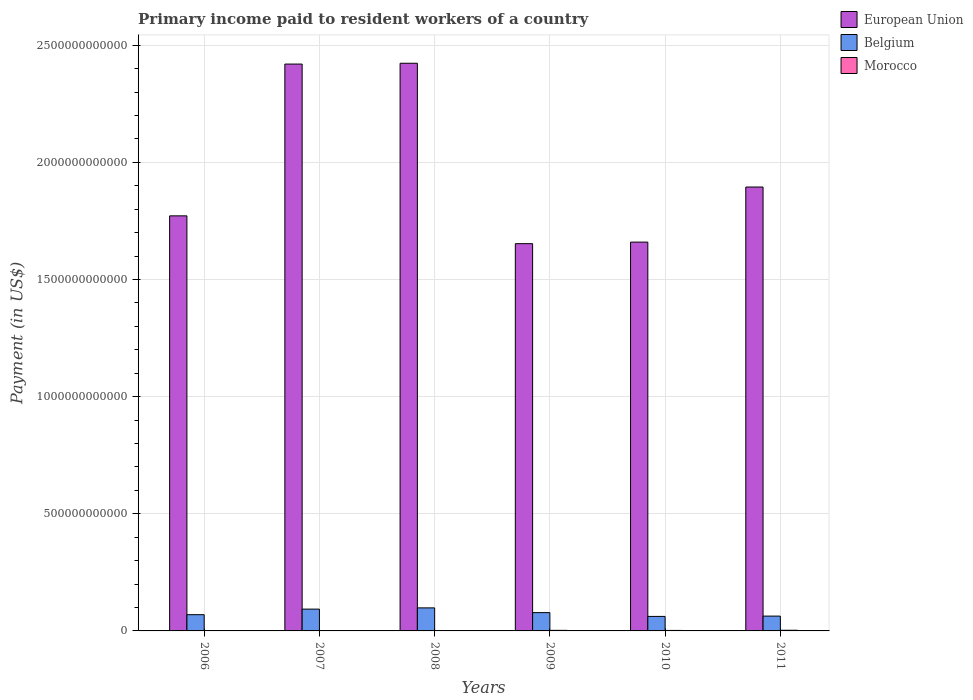How many different coloured bars are there?
Make the answer very short. 3. How many bars are there on the 1st tick from the left?
Give a very brief answer. 3. How many bars are there on the 3rd tick from the right?
Make the answer very short. 3. What is the label of the 3rd group of bars from the left?
Offer a very short reply. 2008. In how many cases, is the number of bars for a given year not equal to the number of legend labels?
Keep it short and to the point. 0. What is the amount paid to workers in Belgium in 2010?
Provide a short and direct response. 6.20e+1. Across all years, what is the maximum amount paid to workers in Morocco?
Keep it short and to the point. 2.86e+09. Across all years, what is the minimum amount paid to workers in European Union?
Offer a terse response. 1.65e+12. In which year was the amount paid to workers in Morocco minimum?
Offer a terse response. 2006. What is the total amount paid to workers in European Union in the graph?
Your response must be concise. 1.18e+13. What is the difference between the amount paid to workers in Morocco in 2009 and that in 2011?
Make the answer very short. -4.36e+08. What is the difference between the amount paid to workers in European Union in 2011 and the amount paid to workers in Morocco in 2008?
Make the answer very short. 1.89e+12. What is the average amount paid to workers in Morocco per year?
Keep it short and to the point. 1.93e+09. In the year 2011, what is the difference between the amount paid to workers in Morocco and amount paid to workers in Belgium?
Provide a short and direct response. -6.04e+1. What is the ratio of the amount paid to workers in Belgium in 2006 to that in 2010?
Offer a terse response. 1.12. Is the amount paid to workers in Belgium in 2008 less than that in 2011?
Provide a short and direct response. No. Is the difference between the amount paid to workers in Morocco in 2006 and 2009 greater than the difference between the amount paid to workers in Belgium in 2006 and 2009?
Keep it short and to the point. Yes. What is the difference between the highest and the second highest amount paid to workers in European Union?
Provide a succinct answer. 3.44e+09. What is the difference between the highest and the lowest amount paid to workers in European Union?
Your answer should be compact. 7.70e+11. Is the sum of the amount paid to workers in Morocco in 2007 and 2009 greater than the maximum amount paid to workers in Belgium across all years?
Make the answer very short. No. What does the 1st bar from the right in 2007 represents?
Give a very brief answer. Morocco. Is it the case that in every year, the sum of the amount paid to workers in Morocco and amount paid to workers in Belgium is greater than the amount paid to workers in European Union?
Keep it short and to the point. No. How many bars are there?
Make the answer very short. 18. Are all the bars in the graph horizontal?
Provide a succinct answer. No. What is the difference between two consecutive major ticks on the Y-axis?
Keep it short and to the point. 5.00e+11. Are the values on the major ticks of Y-axis written in scientific E-notation?
Offer a terse response. No. Does the graph contain any zero values?
Give a very brief answer. No. How many legend labels are there?
Your answer should be very brief. 3. What is the title of the graph?
Give a very brief answer. Primary income paid to resident workers of a country. Does "Costa Rica" appear as one of the legend labels in the graph?
Make the answer very short. No. What is the label or title of the Y-axis?
Offer a very short reply. Payment (in US$). What is the Payment (in US$) of European Union in 2006?
Offer a very short reply. 1.77e+12. What is the Payment (in US$) in Belgium in 2006?
Make the answer very short. 6.93e+1. What is the Payment (in US$) in Morocco in 2006?
Ensure brevity in your answer.  1.23e+09. What is the Payment (in US$) in European Union in 2007?
Provide a short and direct response. 2.42e+12. What is the Payment (in US$) of Belgium in 2007?
Offer a terse response. 9.31e+1. What is the Payment (in US$) of Morocco in 2007?
Provide a succinct answer. 1.37e+09. What is the Payment (in US$) of European Union in 2008?
Keep it short and to the point. 2.42e+12. What is the Payment (in US$) in Belgium in 2008?
Your answer should be compact. 9.83e+1. What is the Payment (in US$) in Morocco in 2008?
Keep it short and to the point. 1.58e+09. What is the Payment (in US$) of European Union in 2009?
Ensure brevity in your answer.  1.65e+12. What is the Payment (in US$) of Belgium in 2009?
Ensure brevity in your answer.  7.81e+1. What is the Payment (in US$) of Morocco in 2009?
Provide a short and direct response. 2.42e+09. What is the Payment (in US$) in European Union in 2010?
Provide a short and direct response. 1.66e+12. What is the Payment (in US$) in Belgium in 2010?
Your answer should be compact. 6.20e+1. What is the Payment (in US$) of Morocco in 2010?
Your answer should be compact. 2.11e+09. What is the Payment (in US$) of European Union in 2011?
Provide a short and direct response. 1.89e+12. What is the Payment (in US$) of Belgium in 2011?
Offer a terse response. 6.33e+1. What is the Payment (in US$) of Morocco in 2011?
Keep it short and to the point. 2.86e+09. Across all years, what is the maximum Payment (in US$) in European Union?
Your answer should be compact. 2.42e+12. Across all years, what is the maximum Payment (in US$) in Belgium?
Give a very brief answer. 9.83e+1. Across all years, what is the maximum Payment (in US$) of Morocco?
Offer a terse response. 2.86e+09. Across all years, what is the minimum Payment (in US$) in European Union?
Offer a very short reply. 1.65e+12. Across all years, what is the minimum Payment (in US$) of Belgium?
Make the answer very short. 6.20e+1. Across all years, what is the minimum Payment (in US$) in Morocco?
Your answer should be compact. 1.23e+09. What is the total Payment (in US$) in European Union in the graph?
Provide a succinct answer. 1.18e+13. What is the total Payment (in US$) in Belgium in the graph?
Your answer should be compact. 4.64e+11. What is the total Payment (in US$) of Morocco in the graph?
Keep it short and to the point. 1.16e+1. What is the difference between the Payment (in US$) of European Union in 2006 and that in 2007?
Make the answer very short. -6.48e+11. What is the difference between the Payment (in US$) of Belgium in 2006 and that in 2007?
Provide a succinct answer. -2.37e+1. What is the difference between the Payment (in US$) of Morocco in 2006 and that in 2007?
Make the answer very short. -1.39e+08. What is the difference between the Payment (in US$) in European Union in 2006 and that in 2008?
Your response must be concise. -6.51e+11. What is the difference between the Payment (in US$) in Belgium in 2006 and that in 2008?
Provide a succinct answer. -2.90e+1. What is the difference between the Payment (in US$) of Morocco in 2006 and that in 2008?
Make the answer very short. -3.54e+08. What is the difference between the Payment (in US$) of European Union in 2006 and that in 2009?
Offer a very short reply. 1.19e+11. What is the difference between the Payment (in US$) of Belgium in 2006 and that in 2009?
Provide a short and direct response. -8.79e+09. What is the difference between the Payment (in US$) of Morocco in 2006 and that in 2009?
Your answer should be compact. -1.19e+09. What is the difference between the Payment (in US$) in European Union in 2006 and that in 2010?
Ensure brevity in your answer.  1.12e+11. What is the difference between the Payment (in US$) in Belgium in 2006 and that in 2010?
Your answer should be compact. 7.37e+09. What is the difference between the Payment (in US$) in Morocco in 2006 and that in 2010?
Ensure brevity in your answer.  -8.83e+08. What is the difference between the Payment (in US$) of European Union in 2006 and that in 2011?
Make the answer very short. -1.23e+11. What is the difference between the Payment (in US$) in Belgium in 2006 and that in 2011?
Offer a very short reply. 6.03e+09. What is the difference between the Payment (in US$) of Morocco in 2006 and that in 2011?
Your answer should be very brief. -1.63e+09. What is the difference between the Payment (in US$) in European Union in 2007 and that in 2008?
Make the answer very short. -3.44e+09. What is the difference between the Payment (in US$) in Belgium in 2007 and that in 2008?
Provide a succinct answer. -5.27e+09. What is the difference between the Payment (in US$) of Morocco in 2007 and that in 2008?
Your answer should be very brief. -2.16e+08. What is the difference between the Payment (in US$) in European Union in 2007 and that in 2009?
Offer a terse response. 7.67e+11. What is the difference between the Payment (in US$) of Belgium in 2007 and that in 2009?
Make the answer very short. 1.50e+1. What is the difference between the Payment (in US$) in Morocco in 2007 and that in 2009?
Give a very brief answer. -1.06e+09. What is the difference between the Payment (in US$) of European Union in 2007 and that in 2010?
Your answer should be very brief. 7.60e+11. What is the difference between the Payment (in US$) of Belgium in 2007 and that in 2010?
Your answer should be very brief. 3.11e+1. What is the difference between the Payment (in US$) in Morocco in 2007 and that in 2010?
Keep it short and to the point. -7.45e+08. What is the difference between the Payment (in US$) in European Union in 2007 and that in 2011?
Make the answer very short. 5.25e+11. What is the difference between the Payment (in US$) of Belgium in 2007 and that in 2011?
Give a very brief answer. 2.98e+1. What is the difference between the Payment (in US$) in Morocco in 2007 and that in 2011?
Make the answer very short. -1.49e+09. What is the difference between the Payment (in US$) of European Union in 2008 and that in 2009?
Ensure brevity in your answer.  7.70e+11. What is the difference between the Payment (in US$) in Belgium in 2008 and that in 2009?
Your answer should be very brief. 2.02e+1. What is the difference between the Payment (in US$) of Morocco in 2008 and that in 2009?
Provide a short and direct response. -8.40e+08. What is the difference between the Payment (in US$) in European Union in 2008 and that in 2010?
Your response must be concise. 7.63e+11. What is the difference between the Payment (in US$) of Belgium in 2008 and that in 2010?
Make the answer very short. 3.64e+1. What is the difference between the Payment (in US$) of Morocco in 2008 and that in 2010?
Give a very brief answer. -5.29e+08. What is the difference between the Payment (in US$) in European Union in 2008 and that in 2011?
Provide a short and direct response. 5.28e+11. What is the difference between the Payment (in US$) in Belgium in 2008 and that in 2011?
Ensure brevity in your answer.  3.51e+1. What is the difference between the Payment (in US$) of Morocco in 2008 and that in 2011?
Give a very brief answer. -1.28e+09. What is the difference between the Payment (in US$) in European Union in 2009 and that in 2010?
Your response must be concise. -6.65e+09. What is the difference between the Payment (in US$) of Belgium in 2009 and that in 2010?
Make the answer very short. 1.62e+1. What is the difference between the Payment (in US$) of Morocco in 2009 and that in 2010?
Give a very brief answer. 3.10e+08. What is the difference between the Payment (in US$) in European Union in 2009 and that in 2011?
Keep it short and to the point. -2.42e+11. What is the difference between the Payment (in US$) in Belgium in 2009 and that in 2011?
Offer a very short reply. 1.48e+1. What is the difference between the Payment (in US$) in Morocco in 2009 and that in 2011?
Offer a terse response. -4.36e+08. What is the difference between the Payment (in US$) in European Union in 2010 and that in 2011?
Keep it short and to the point. -2.35e+11. What is the difference between the Payment (in US$) in Belgium in 2010 and that in 2011?
Your answer should be very brief. -1.34e+09. What is the difference between the Payment (in US$) in Morocco in 2010 and that in 2011?
Give a very brief answer. -7.46e+08. What is the difference between the Payment (in US$) in European Union in 2006 and the Payment (in US$) in Belgium in 2007?
Give a very brief answer. 1.68e+12. What is the difference between the Payment (in US$) in European Union in 2006 and the Payment (in US$) in Morocco in 2007?
Offer a very short reply. 1.77e+12. What is the difference between the Payment (in US$) of Belgium in 2006 and the Payment (in US$) of Morocco in 2007?
Give a very brief answer. 6.80e+1. What is the difference between the Payment (in US$) in European Union in 2006 and the Payment (in US$) in Belgium in 2008?
Your answer should be compact. 1.67e+12. What is the difference between the Payment (in US$) in European Union in 2006 and the Payment (in US$) in Morocco in 2008?
Offer a terse response. 1.77e+12. What is the difference between the Payment (in US$) of Belgium in 2006 and the Payment (in US$) of Morocco in 2008?
Make the answer very short. 6.77e+1. What is the difference between the Payment (in US$) of European Union in 2006 and the Payment (in US$) of Belgium in 2009?
Give a very brief answer. 1.69e+12. What is the difference between the Payment (in US$) in European Union in 2006 and the Payment (in US$) in Morocco in 2009?
Your response must be concise. 1.77e+12. What is the difference between the Payment (in US$) in Belgium in 2006 and the Payment (in US$) in Morocco in 2009?
Provide a short and direct response. 6.69e+1. What is the difference between the Payment (in US$) in European Union in 2006 and the Payment (in US$) in Belgium in 2010?
Offer a terse response. 1.71e+12. What is the difference between the Payment (in US$) in European Union in 2006 and the Payment (in US$) in Morocco in 2010?
Ensure brevity in your answer.  1.77e+12. What is the difference between the Payment (in US$) of Belgium in 2006 and the Payment (in US$) of Morocco in 2010?
Offer a very short reply. 6.72e+1. What is the difference between the Payment (in US$) in European Union in 2006 and the Payment (in US$) in Belgium in 2011?
Offer a very short reply. 1.71e+12. What is the difference between the Payment (in US$) in European Union in 2006 and the Payment (in US$) in Morocco in 2011?
Your response must be concise. 1.77e+12. What is the difference between the Payment (in US$) in Belgium in 2006 and the Payment (in US$) in Morocco in 2011?
Keep it short and to the point. 6.65e+1. What is the difference between the Payment (in US$) in European Union in 2007 and the Payment (in US$) in Belgium in 2008?
Make the answer very short. 2.32e+12. What is the difference between the Payment (in US$) of European Union in 2007 and the Payment (in US$) of Morocco in 2008?
Give a very brief answer. 2.42e+12. What is the difference between the Payment (in US$) of Belgium in 2007 and the Payment (in US$) of Morocco in 2008?
Make the answer very short. 9.15e+1. What is the difference between the Payment (in US$) in European Union in 2007 and the Payment (in US$) in Belgium in 2009?
Your answer should be compact. 2.34e+12. What is the difference between the Payment (in US$) in European Union in 2007 and the Payment (in US$) in Morocco in 2009?
Your response must be concise. 2.42e+12. What is the difference between the Payment (in US$) in Belgium in 2007 and the Payment (in US$) in Morocco in 2009?
Provide a short and direct response. 9.07e+1. What is the difference between the Payment (in US$) of European Union in 2007 and the Payment (in US$) of Belgium in 2010?
Make the answer very short. 2.36e+12. What is the difference between the Payment (in US$) in European Union in 2007 and the Payment (in US$) in Morocco in 2010?
Ensure brevity in your answer.  2.42e+12. What is the difference between the Payment (in US$) of Belgium in 2007 and the Payment (in US$) of Morocco in 2010?
Provide a succinct answer. 9.10e+1. What is the difference between the Payment (in US$) in European Union in 2007 and the Payment (in US$) in Belgium in 2011?
Your answer should be very brief. 2.36e+12. What is the difference between the Payment (in US$) of European Union in 2007 and the Payment (in US$) of Morocco in 2011?
Your answer should be very brief. 2.42e+12. What is the difference between the Payment (in US$) in Belgium in 2007 and the Payment (in US$) in Morocco in 2011?
Keep it short and to the point. 9.02e+1. What is the difference between the Payment (in US$) in European Union in 2008 and the Payment (in US$) in Belgium in 2009?
Offer a very short reply. 2.35e+12. What is the difference between the Payment (in US$) of European Union in 2008 and the Payment (in US$) of Morocco in 2009?
Ensure brevity in your answer.  2.42e+12. What is the difference between the Payment (in US$) in Belgium in 2008 and the Payment (in US$) in Morocco in 2009?
Offer a very short reply. 9.59e+1. What is the difference between the Payment (in US$) of European Union in 2008 and the Payment (in US$) of Belgium in 2010?
Provide a short and direct response. 2.36e+12. What is the difference between the Payment (in US$) of European Union in 2008 and the Payment (in US$) of Morocco in 2010?
Offer a very short reply. 2.42e+12. What is the difference between the Payment (in US$) of Belgium in 2008 and the Payment (in US$) of Morocco in 2010?
Keep it short and to the point. 9.62e+1. What is the difference between the Payment (in US$) of European Union in 2008 and the Payment (in US$) of Belgium in 2011?
Your answer should be very brief. 2.36e+12. What is the difference between the Payment (in US$) in European Union in 2008 and the Payment (in US$) in Morocco in 2011?
Your response must be concise. 2.42e+12. What is the difference between the Payment (in US$) of Belgium in 2008 and the Payment (in US$) of Morocco in 2011?
Offer a terse response. 9.55e+1. What is the difference between the Payment (in US$) of European Union in 2009 and the Payment (in US$) of Belgium in 2010?
Make the answer very short. 1.59e+12. What is the difference between the Payment (in US$) in European Union in 2009 and the Payment (in US$) in Morocco in 2010?
Provide a short and direct response. 1.65e+12. What is the difference between the Payment (in US$) of Belgium in 2009 and the Payment (in US$) of Morocco in 2010?
Provide a succinct answer. 7.60e+1. What is the difference between the Payment (in US$) in European Union in 2009 and the Payment (in US$) in Belgium in 2011?
Your response must be concise. 1.59e+12. What is the difference between the Payment (in US$) in European Union in 2009 and the Payment (in US$) in Morocco in 2011?
Your answer should be compact. 1.65e+12. What is the difference between the Payment (in US$) in Belgium in 2009 and the Payment (in US$) in Morocco in 2011?
Offer a terse response. 7.53e+1. What is the difference between the Payment (in US$) in European Union in 2010 and the Payment (in US$) in Belgium in 2011?
Your answer should be compact. 1.60e+12. What is the difference between the Payment (in US$) of European Union in 2010 and the Payment (in US$) of Morocco in 2011?
Offer a terse response. 1.66e+12. What is the difference between the Payment (in US$) of Belgium in 2010 and the Payment (in US$) of Morocco in 2011?
Your answer should be very brief. 5.91e+1. What is the average Payment (in US$) in European Union per year?
Give a very brief answer. 1.97e+12. What is the average Payment (in US$) of Belgium per year?
Give a very brief answer. 7.73e+1. What is the average Payment (in US$) in Morocco per year?
Your answer should be compact. 1.93e+09. In the year 2006, what is the difference between the Payment (in US$) in European Union and Payment (in US$) in Belgium?
Offer a very short reply. 1.70e+12. In the year 2006, what is the difference between the Payment (in US$) in European Union and Payment (in US$) in Morocco?
Your answer should be compact. 1.77e+12. In the year 2006, what is the difference between the Payment (in US$) of Belgium and Payment (in US$) of Morocco?
Provide a succinct answer. 6.81e+1. In the year 2007, what is the difference between the Payment (in US$) of European Union and Payment (in US$) of Belgium?
Offer a very short reply. 2.33e+12. In the year 2007, what is the difference between the Payment (in US$) of European Union and Payment (in US$) of Morocco?
Offer a very short reply. 2.42e+12. In the year 2007, what is the difference between the Payment (in US$) in Belgium and Payment (in US$) in Morocco?
Ensure brevity in your answer.  9.17e+1. In the year 2008, what is the difference between the Payment (in US$) in European Union and Payment (in US$) in Belgium?
Provide a short and direct response. 2.32e+12. In the year 2008, what is the difference between the Payment (in US$) in European Union and Payment (in US$) in Morocco?
Ensure brevity in your answer.  2.42e+12. In the year 2008, what is the difference between the Payment (in US$) in Belgium and Payment (in US$) in Morocco?
Offer a terse response. 9.68e+1. In the year 2009, what is the difference between the Payment (in US$) of European Union and Payment (in US$) of Belgium?
Make the answer very short. 1.57e+12. In the year 2009, what is the difference between the Payment (in US$) of European Union and Payment (in US$) of Morocco?
Offer a very short reply. 1.65e+12. In the year 2009, what is the difference between the Payment (in US$) in Belgium and Payment (in US$) in Morocco?
Your answer should be very brief. 7.57e+1. In the year 2010, what is the difference between the Payment (in US$) of European Union and Payment (in US$) of Belgium?
Your response must be concise. 1.60e+12. In the year 2010, what is the difference between the Payment (in US$) of European Union and Payment (in US$) of Morocco?
Provide a succinct answer. 1.66e+12. In the year 2010, what is the difference between the Payment (in US$) of Belgium and Payment (in US$) of Morocco?
Your response must be concise. 5.98e+1. In the year 2011, what is the difference between the Payment (in US$) of European Union and Payment (in US$) of Belgium?
Provide a short and direct response. 1.83e+12. In the year 2011, what is the difference between the Payment (in US$) of European Union and Payment (in US$) of Morocco?
Your response must be concise. 1.89e+12. In the year 2011, what is the difference between the Payment (in US$) of Belgium and Payment (in US$) of Morocco?
Your answer should be compact. 6.04e+1. What is the ratio of the Payment (in US$) in European Union in 2006 to that in 2007?
Make the answer very short. 0.73. What is the ratio of the Payment (in US$) in Belgium in 2006 to that in 2007?
Your response must be concise. 0.74. What is the ratio of the Payment (in US$) in Morocco in 2006 to that in 2007?
Provide a short and direct response. 0.9. What is the ratio of the Payment (in US$) in European Union in 2006 to that in 2008?
Provide a short and direct response. 0.73. What is the ratio of the Payment (in US$) of Belgium in 2006 to that in 2008?
Make the answer very short. 0.7. What is the ratio of the Payment (in US$) in Morocco in 2006 to that in 2008?
Offer a terse response. 0.78. What is the ratio of the Payment (in US$) of European Union in 2006 to that in 2009?
Keep it short and to the point. 1.07. What is the ratio of the Payment (in US$) of Belgium in 2006 to that in 2009?
Ensure brevity in your answer.  0.89. What is the ratio of the Payment (in US$) in Morocco in 2006 to that in 2009?
Keep it short and to the point. 0.51. What is the ratio of the Payment (in US$) of European Union in 2006 to that in 2010?
Give a very brief answer. 1.07. What is the ratio of the Payment (in US$) in Belgium in 2006 to that in 2010?
Your response must be concise. 1.12. What is the ratio of the Payment (in US$) of Morocco in 2006 to that in 2010?
Your answer should be very brief. 0.58. What is the ratio of the Payment (in US$) of European Union in 2006 to that in 2011?
Your answer should be compact. 0.94. What is the ratio of the Payment (in US$) of Belgium in 2006 to that in 2011?
Offer a terse response. 1.1. What is the ratio of the Payment (in US$) in Morocco in 2006 to that in 2011?
Offer a terse response. 0.43. What is the ratio of the Payment (in US$) in Belgium in 2007 to that in 2008?
Your answer should be very brief. 0.95. What is the ratio of the Payment (in US$) in Morocco in 2007 to that in 2008?
Ensure brevity in your answer.  0.86. What is the ratio of the Payment (in US$) in European Union in 2007 to that in 2009?
Provide a succinct answer. 1.46. What is the ratio of the Payment (in US$) in Belgium in 2007 to that in 2009?
Provide a succinct answer. 1.19. What is the ratio of the Payment (in US$) in Morocco in 2007 to that in 2009?
Provide a short and direct response. 0.56. What is the ratio of the Payment (in US$) of European Union in 2007 to that in 2010?
Provide a short and direct response. 1.46. What is the ratio of the Payment (in US$) in Belgium in 2007 to that in 2010?
Make the answer very short. 1.5. What is the ratio of the Payment (in US$) in Morocco in 2007 to that in 2010?
Offer a very short reply. 0.65. What is the ratio of the Payment (in US$) of European Union in 2007 to that in 2011?
Your response must be concise. 1.28. What is the ratio of the Payment (in US$) in Belgium in 2007 to that in 2011?
Your answer should be compact. 1.47. What is the ratio of the Payment (in US$) of Morocco in 2007 to that in 2011?
Ensure brevity in your answer.  0.48. What is the ratio of the Payment (in US$) in European Union in 2008 to that in 2009?
Keep it short and to the point. 1.47. What is the ratio of the Payment (in US$) of Belgium in 2008 to that in 2009?
Your answer should be compact. 1.26. What is the ratio of the Payment (in US$) in Morocco in 2008 to that in 2009?
Provide a short and direct response. 0.65. What is the ratio of the Payment (in US$) in European Union in 2008 to that in 2010?
Your answer should be compact. 1.46. What is the ratio of the Payment (in US$) in Belgium in 2008 to that in 2010?
Your answer should be compact. 1.59. What is the ratio of the Payment (in US$) in Morocco in 2008 to that in 2010?
Offer a very short reply. 0.75. What is the ratio of the Payment (in US$) in European Union in 2008 to that in 2011?
Your answer should be very brief. 1.28. What is the ratio of the Payment (in US$) of Belgium in 2008 to that in 2011?
Offer a terse response. 1.55. What is the ratio of the Payment (in US$) of Morocco in 2008 to that in 2011?
Ensure brevity in your answer.  0.55. What is the ratio of the Payment (in US$) in Belgium in 2009 to that in 2010?
Keep it short and to the point. 1.26. What is the ratio of the Payment (in US$) in Morocco in 2009 to that in 2010?
Provide a short and direct response. 1.15. What is the ratio of the Payment (in US$) in European Union in 2009 to that in 2011?
Ensure brevity in your answer.  0.87. What is the ratio of the Payment (in US$) of Belgium in 2009 to that in 2011?
Give a very brief answer. 1.23. What is the ratio of the Payment (in US$) of Morocco in 2009 to that in 2011?
Ensure brevity in your answer.  0.85. What is the ratio of the Payment (in US$) of European Union in 2010 to that in 2011?
Your answer should be compact. 0.88. What is the ratio of the Payment (in US$) in Belgium in 2010 to that in 2011?
Offer a terse response. 0.98. What is the ratio of the Payment (in US$) of Morocco in 2010 to that in 2011?
Your answer should be compact. 0.74. What is the difference between the highest and the second highest Payment (in US$) in European Union?
Ensure brevity in your answer.  3.44e+09. What is the difference between the highest and the second highest Payment (in US$) in Belgium?
Provide a succinct answer. 5.27e+09. What is the difference between the highest and the second highest Payment (in US$) of Morocco?
Your answer should be very brief. 4.36e+08. What is the difference between the highest and the lowest Payment (in US$) of European Union?
Your answer should be very brief. 7.70e+11. What is the difference between the highest and the lowest Payment (in US$) of Belgium?
Offer a terse response. 3.64e+1. What is the difference between the highest and the lowest Payment (in US$) in Morocco?
Your response must be concise. 1.63e+09. 